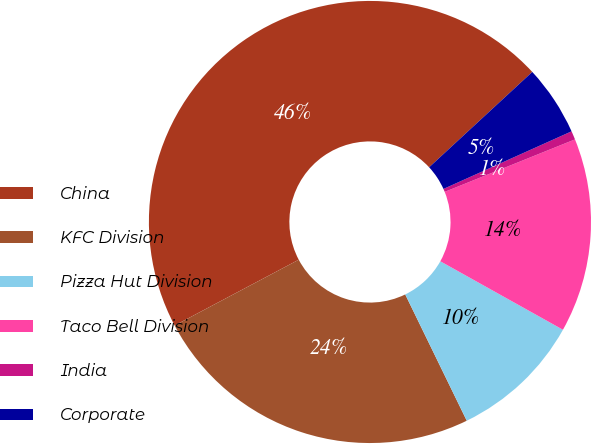Convert chart to OTSL. <chart><loc_0><loc_0><loc_500><loc_500><pie_chart><fcel>China<fcel>KFC Division<fcel>Pizza Hut Division<fcel>Taco Bell Division<fcel>India<fcel>Corporate<nl><fcel>45.88%<fcel>24.46%<fcel>9.68%<fcel>14.2%<fcel>0.63%<fcel>5.15%<nl></chart> 